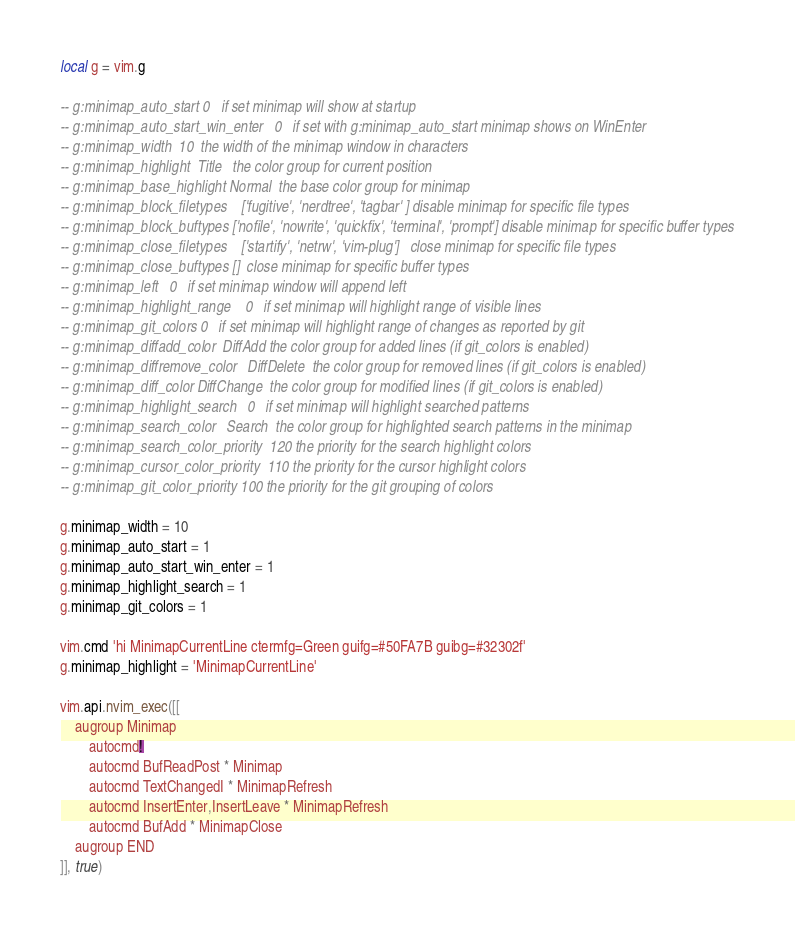Convert code to text. <code><loc_0><loc_0><loc_500><loc_500><_Lua_>local g = vim.g

-- g:minimap_auto_start	0	if set minimap will show at startup
-- g:minimap_auto_start_win_enter	0	if set with g:minimap_auto_start minimap shows on WinEnter
-- g:minimap_width	10	the width of the minimap window in characters
-- g:minimap_highlight	Title	the color group for current position
-- g:minimap_base_highlight	Normal	the base color group for minimap
-- g:minimap_block_filetypes	['fugitive', 'nerdtree', 'tagbar' ]	disable minimap for specific file types
-- g:minimap_block_buftypes	['nofile', 'nowrite', 'quickfix', 'terminal', 'prompt']	disable minimap for specific buffer types
-- g:minimap_close_filetypes	['startify', 'netrw', 'vim-plug']	close minimap for specific file types
-- g:minimap_close_buftypes	[]	close minimap for specific buffer types
-- g:minimap_left	0	if set minimap window will append left
-- g:minimap_highlight_range	0	if set minimap will highlight range of visible lines
-- g:minimap_git_colors	0	if set minimap will highlight range of changes as reported by git
-- g:minimap_diffadd_color	DiffAdd	the color group for added lines (if git_colors is enabled)
-- g:minimap_diffremove_color	DiffDelete	the color group for removed lines (if git_colors is enabled)
-- g:minimap_diff_color	DiffChange	the color group for modified lines (if git_colors is enabled)
-- g:minimap_highlight_search	0	if set minimap will highlight searched patterns
-- g:minimap_search_color	Search	the color group for highlighted search patterns in the minimap
-- g:minimap_search_color_priority	120	the priority for the search highlight colors
-- g:minimap_cursor_color_priority	110	the priority for the cursor highlight colors
-- g:minimap_git_color_priority	100	the priority for the git grouping of colors

g.minimap_width = 10
g.minimap_auto_start = 1
g.minimap_auto_start_win_enter = 1
g.minimap_highlight_search = 1
g.minimap_git_colors = 1

vim.cmd 'hi MinimapCurrentLine ctermfg=Green guifg=#50FA7B guibg=#32302f'
g.minimap_highlight = 'MinimapCurrentLine'

vim.api.nvim_exec([[
	augroup Minimap
		autocmd!
		autocmd BufReadPost * Minimap
		autocmd TextChangedI * MinimapRefresh
		autocmd InsertEnter,InsertLeave * MinimapRefresh
		autocmd BufAdd * MinimapClose
	augroup END
]], true)

</code> 